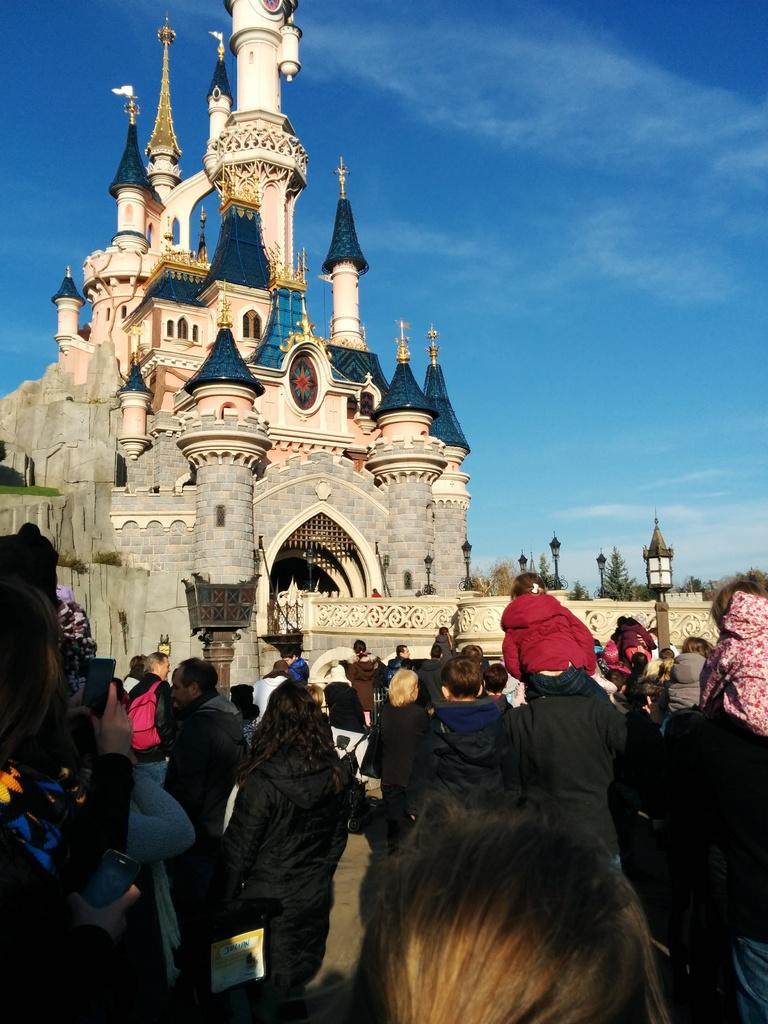Please provide a concise description of this image. In this image there are group of people standing, lights, poles, building, trees,sky. 